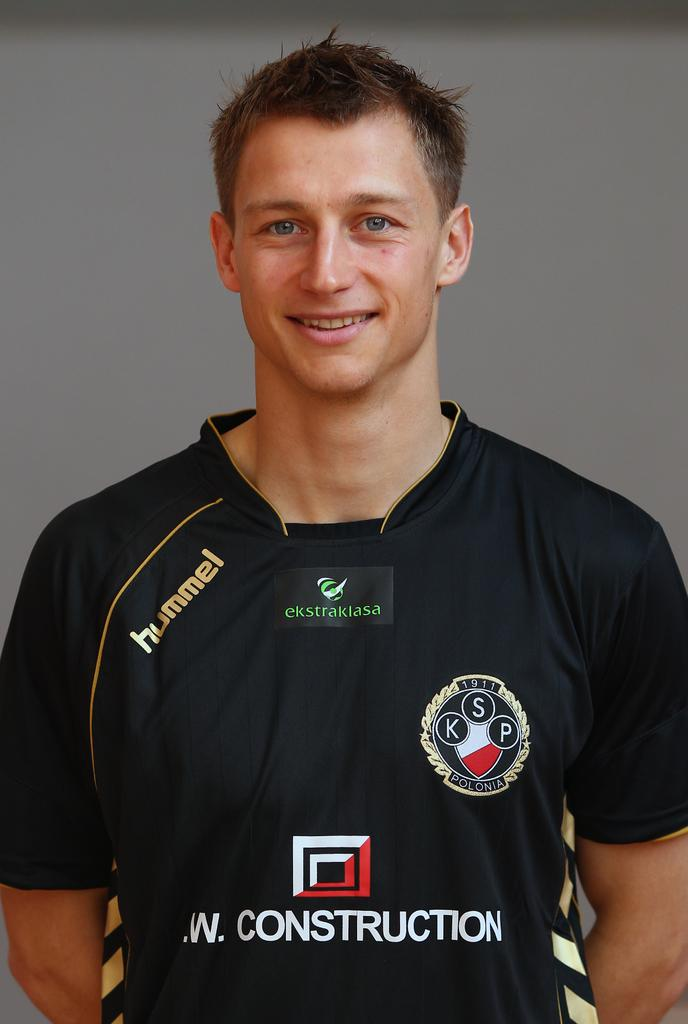<image>
Write a terse but informative summary of the picture. A player's jersey has the word "hummel" on one shoulder. 